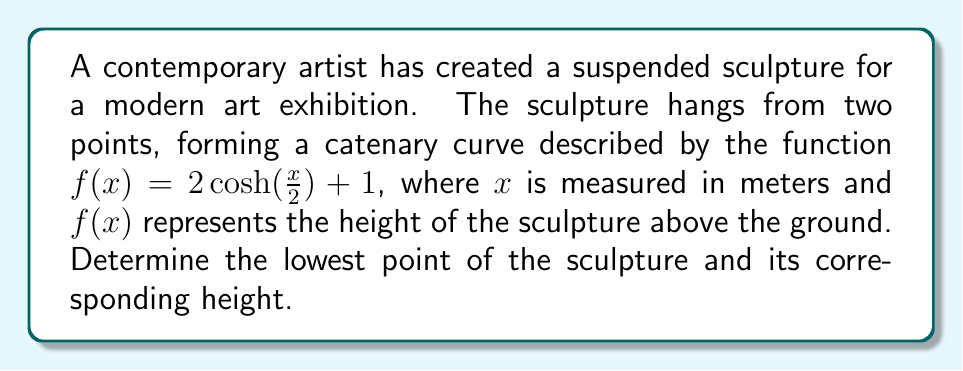Can you answer this question? To find the lowest point of the suspended sculpture, we need to determine the minimum of the given function $f(x) = 2 \cosh(\frac{x}{2}) + 1$. Here's how we can do this:

1) The lowest point of a catenary curve occurs at its vertex, which is always at the midpoint between the two suspension points.

2) For a catenary curve, the vertex occurs where the derivative of the function equals zero. So, let's find the derivative of $f(x)$:

   $f'(x) = 2 \cdot \frac{1}{2} \sinh(\frac{x}{2}) = \sinh(\frac{x}{2})$

3) Set the derivative equal to zero and solve for x:

   $\sinh(\frac{x}{2}) = 0$
   $\frac{x}{2} = 0$
   $x = 0$

4) This confirms that the lowest point occurs at $x = 0$, which is the midpoint of the sculpture.

5) To find the height of the lowest point, we evaluate $f(x)$ at $x = 0$:

   $f(0) = 2 \cosh(0) + 1$
   $= 2 \cdot 1 + 1$
   $= 3$

Therefore, the lowest point of the sculpture occurs at $x = 0$ meters, and its height above the ground is 3 meters.
Answer: $(0, 3)$ 